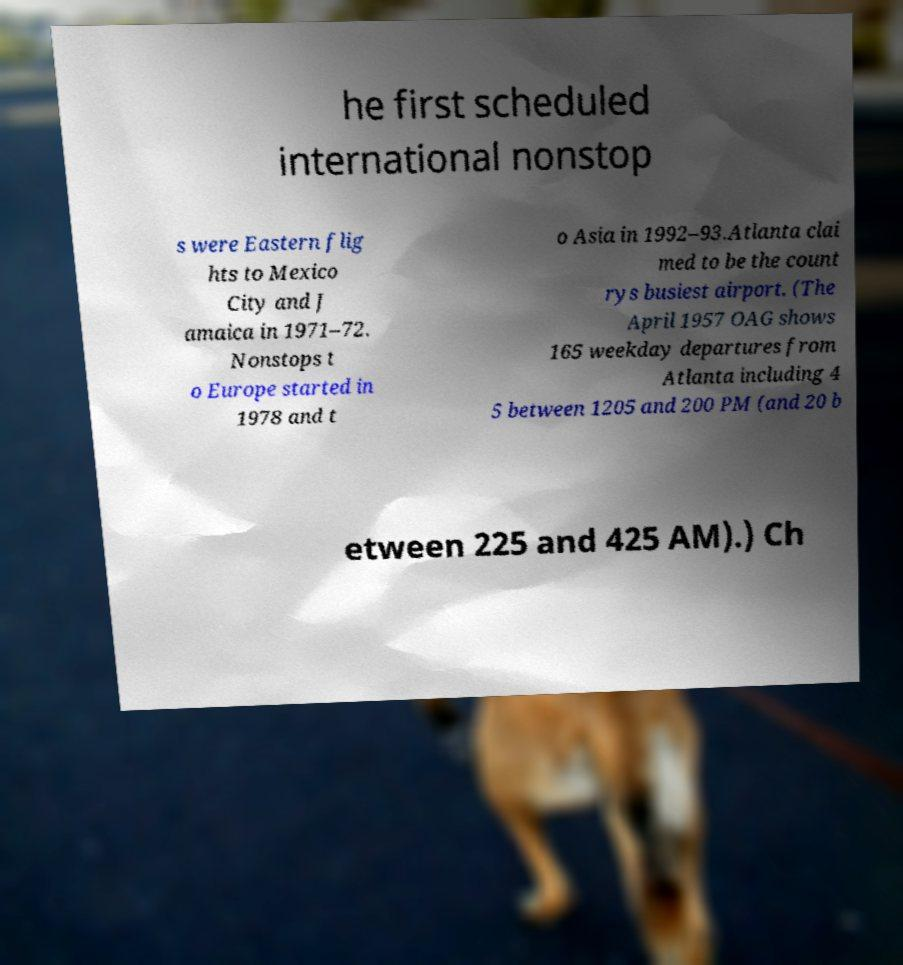Can you read and provide the text displayed in the image?This photo seems to have some interesting text. Can you extract and type it out for me? he first scheduled international nonstop s were Eastern flig hts to Mexico City and J amaica in 1971–72. Nonstops t o Europe started in 1978 and t o Asia in 1992–93.Atlanta clai med to be the count rys busiest airport. (The April 1957 OAG shows 165 weekday departures from Atlanta including 4 5 between 1205 and 200 PM (and 20 b etween 225 and 425 AM).) Ch 